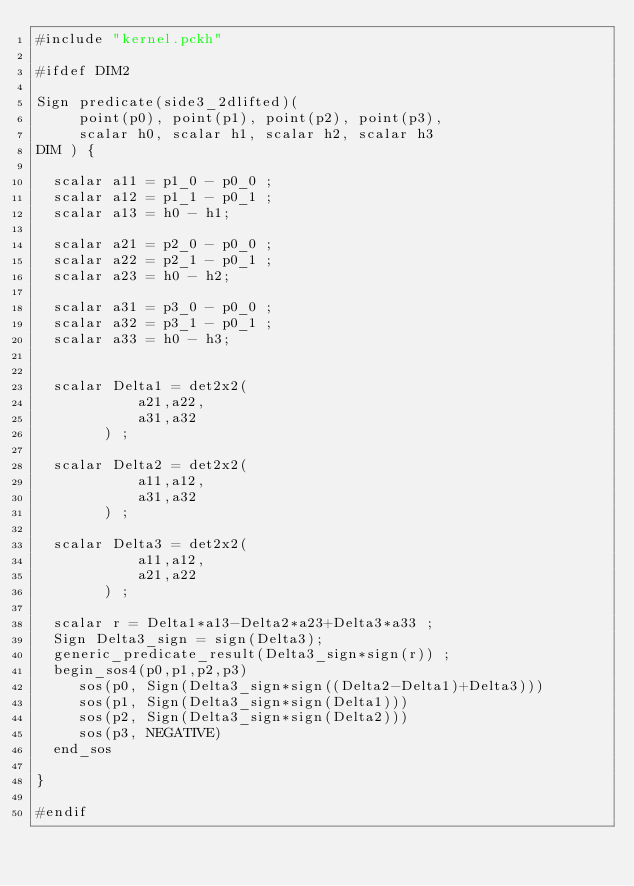Convert code to text. <code><loc_0><loc_0><loc_500><loc_500><_SQL_>#include "kernel.pckh"

#ifdef DIM2

Sign predicate(side3_2dlifted)(
     point(p0), point(p1), point(p2), point(p3),
     scalar h0, scalar h1, scalar h2, scalar h3
DIM ) {

  scalar a11 = p1_0 - p0_0 ;
  scalar a12 = p1_1 - p0_1 ;
  scalar a13 = h0 - h1;

  scalar a21 = p2_0 - p0_0 ;
  scalar a22 = p2_1 - p0_1 ;
  scalar a23 = h0 - h2;

  scalar a31 = p3_0 - p0_0 ;
  scalar a32 = p3_1 - p0_1 ;
  scalar a33 = h0 - h3;


  scalar Delta1 = det2x2(
            a21,a22,
            a31,a32
        ) ;
  
  scalar Delta2 = det2x2(
            a11,a12,
            a31,a32
        ) ;
 
  scalar Delta3 = det2x2(
            a11,a12,
            a21,a22
        ) ;
 
  scalar r = Delta1*a13-Delta2*a23+Delta3*a33 ;
  Sign Delta3_sign = sign(Delta3);
  generic_predicate_result(Delta3_sign*sign(r)) ;
  begin_sos4(p0,p1,p2,p3)
     sos(p0, Sign(Delta3_sign*sign((Delta2-Delta1)+Delta3)))
     sos(p1, Sign(Delta3_sign*sign(Delta1)))
     sos(p2, Sign(Delta3_sign*sign(Delta2)))
     sos(p3, NEGATIVE)
  end_sos

}

#endif
</code> 